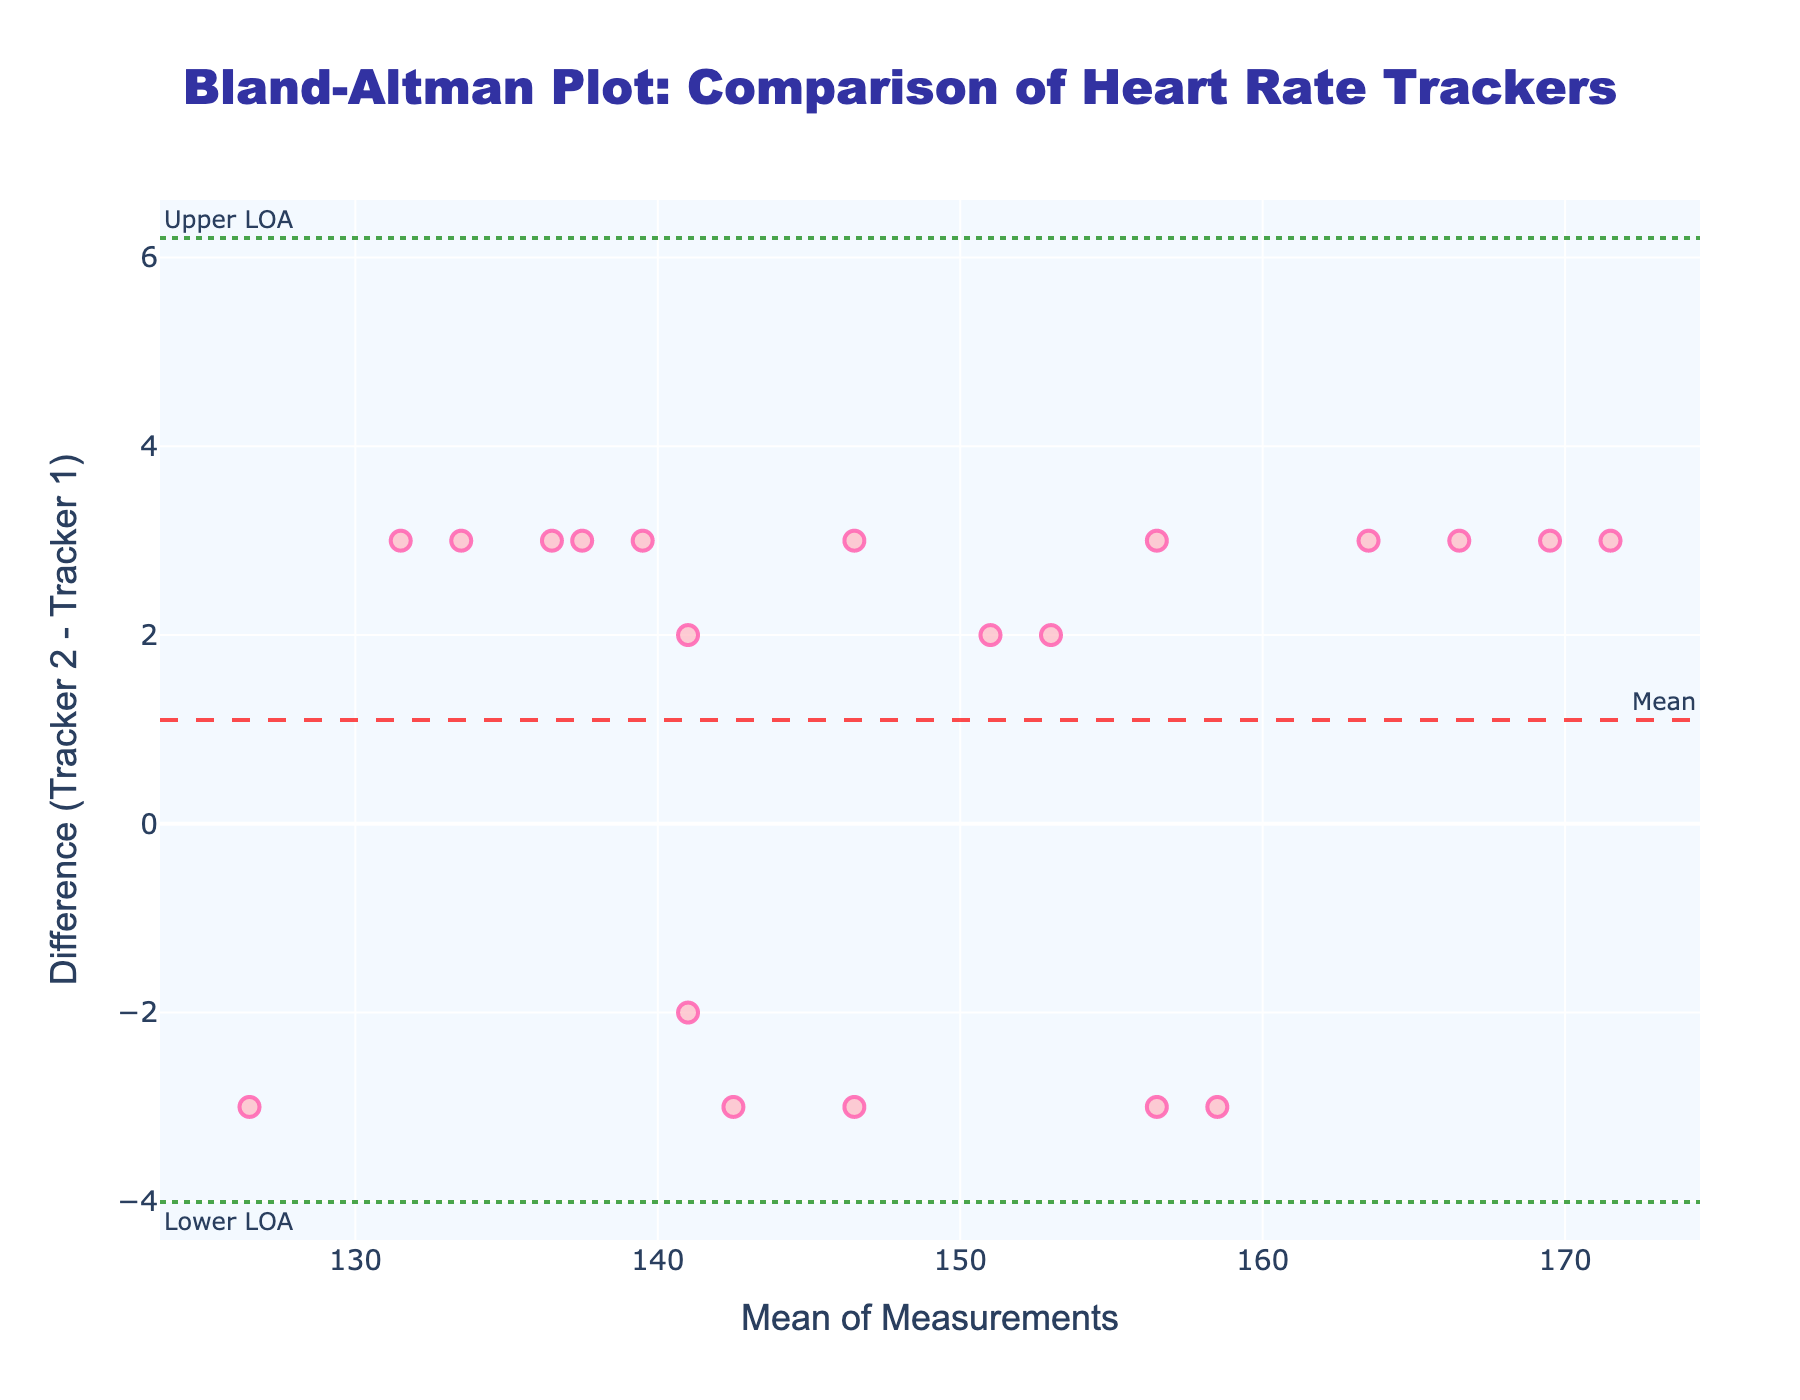What's the title of the plot? The title is displayed at the top center of the plot and reads "Bland-Altman Plot: Comparison of Heart Rate Trackers"
Answer: Bland-Altman Plot: Comparison of Heart Rate Trackers How many data points are plotted? The plot has one mark per data point, each representing a pair of measurements from the two trackers. By counting the marks, we see there are 20 data points.
Answer: 20 What is the range of differences between the two trackers? The differences (y-axis values) range from the smallest value to the highest value, which are -3 and 3, respectively.
Answer: -3 to 3 What are the mean and standard deviation of the differences? The mean difference is marked by a dashed horizontal line, and the values for standard deviation lines (limits of agreement) can be inferred from the plot's annotations for LOA. Calculating these we get: Mean Diff = 1; STD Diff ≈ 3.
Answer: Mean: 1, Std Dev: ≈3 What are the upper and lower limits of agreement (LOA)? The upper LOA is calculated as Mean Diff + 1.96 * Std Dev, and the lower LOA as Mean Diff - 1.96 * Std Dev. This gives us approximately: Upper LOA = 1 + 1.96*(3) = 6.88; Lower LOA = 1 - 1.96*(3) = -4.88. Both values are denoted by dotted horizontal lines on the plot.
Answer: Upper LOA: 6.88, Lower LOA: -4.88 Are there any data points outside the limits of agreement? To find if any points lie outside the LOA, we inspect if any markers are above the upper dotted line (around 6.88) or below the lower dotted line (around -4.88). None of the markers exceed these boundaries.
Answer: No What does a positive difference indicate and is it consistent across the plot? A positive difference (Tracker 2 - Tracker 1) indicates that Tracker 2 recorded a higher heart rate than Tracker 1. Observing the plot, you can see that many points fall above the zero line indicating higher readings from Tracker 2.
Answer: Tracker 2 generally records higher HR How close are the trackers on average? The mean difference of 1 and the narrow range of differences between -3 to 3 suggest that the trackers' measurements are overall quite similar, with an average discrepancy of only 1 beat per minute.
Answer: 1 beat per minute on average What can we deduce from this Bland-Altman plot about the agreement between the two fitness trackers? The plot indicates that the two fitness trackers generally agree well, as the differences are small (around 3 beats per minute) with a mean difference close to zero. This suggests minimal systematic bias and good agreement overall.
Answer: Good agreement 